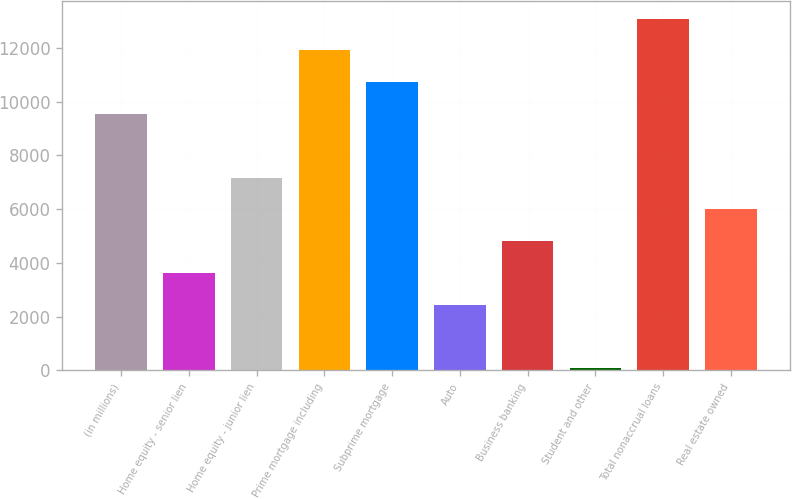<chart> <loc_0><loc_0><loc_500><loc_500><bar_chart><fcel>(in millions)<fcel>Home equity - senior lien<fcel>Home equity - junior lien<fcel>Prime mortgage including<fcel>Subprime mortgage<fcel>Auto<fcel>Business banking<fcel>Student and other<fcel>Total nonaccrual loans<fcel>Real estate owned<nl><fcel>9544.4<fcel>3625.4<fcel>7176.8<fcel>11912<fcel>10728.2<fcel>2441.6<fcel>4809.2<fcel>74<fcel>13095.8<fcel>5993<nl></chart> 